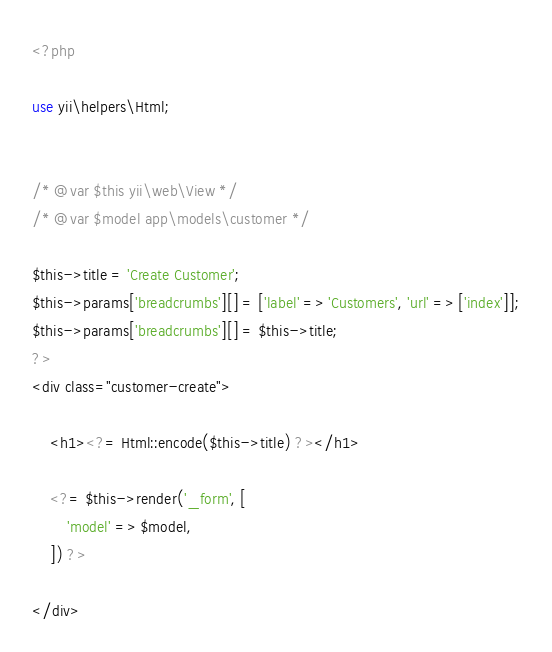<code> <loc_0><loc_0><loc_500><loc_500><_PHP_><?php

use yii\helpers\Html;


/* @var $this yii\web\View */
/* @var $model app\models\customer */

$this->title = 'Create Customer';
$this->params['breadcrumbs'][] = ['label' => 'Customers', 'url' => ['index']];
$this->params['breadcrumbs'][] = $this->title;
?>
<div class="customer-create">

    <h1><?= Html::encode($this->title) ?></h1>

    <?= $this->render('_form', [
        'model' => $model,
    ]) ?>

</div>
</code> 